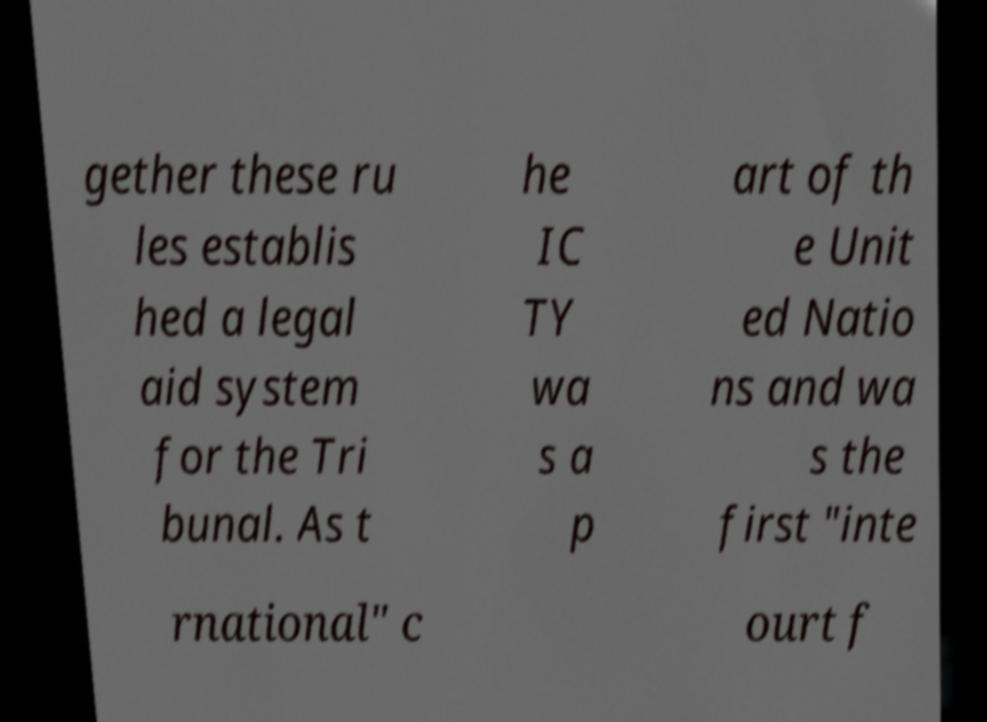There's text embedded in this image that I need extracted. Can you transcribe it verbatim? gether these ru les establis hed a legal aid system for the Tri bunal. As t he IC TY wa s a p art of th e Unit ed Natio ns and wa s the first "inte rnational" c ourt f 